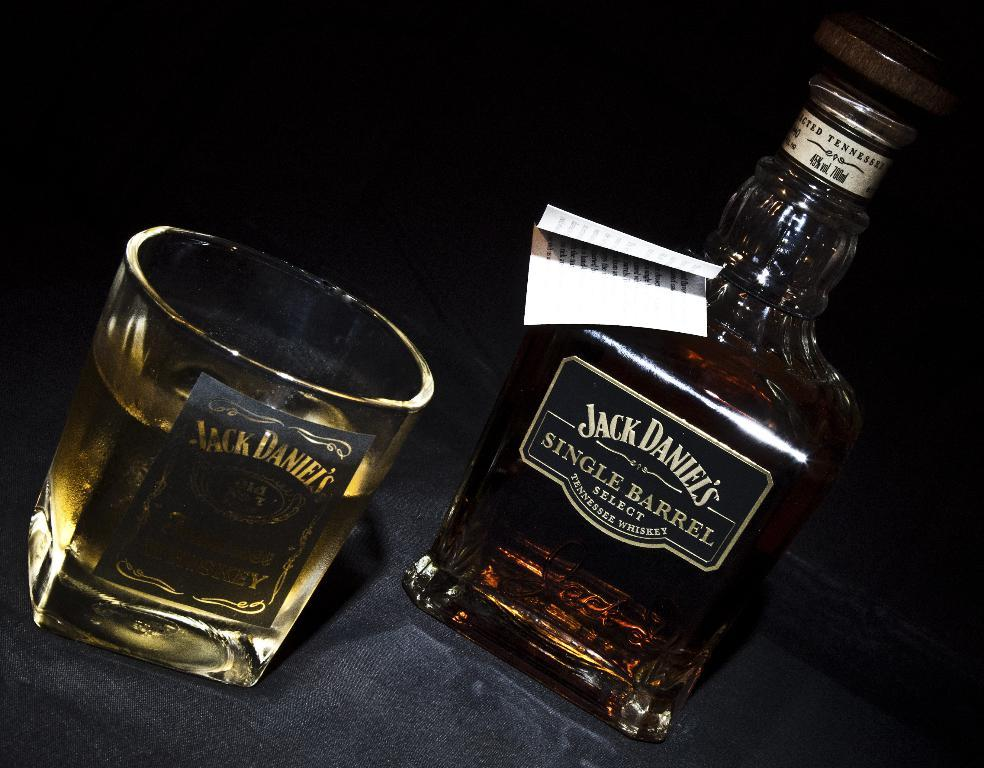What is attached to the bottle in the image? There is a paper attached to the bottle in the image. What can be seen in the glass in the image? There is a drink in the glass in the image. How does the jellyfish move in the image? There is no jellyfish present in the image. Can you describe the sink in the image? There is no sink present in the image. 